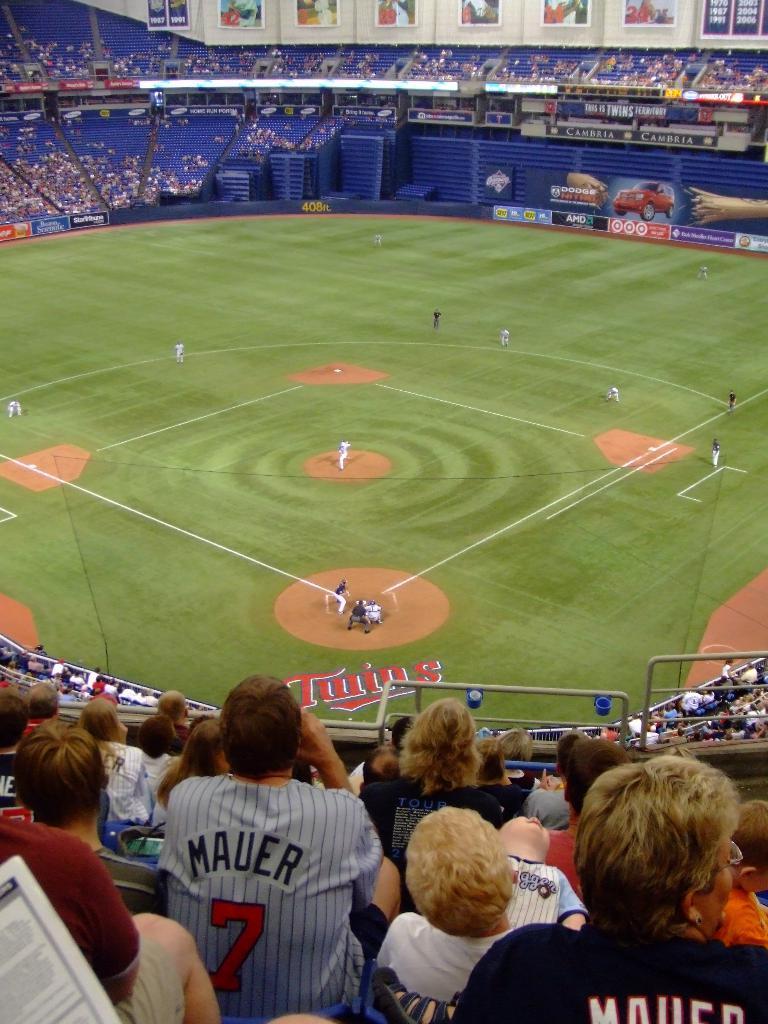In one or two sentences, can you explain what this image depicts? This image consists of a stadium. In which few persons are playing cricket. And we can see a huge crowd in the stadium. In the front, we can see the frames hanged on the wall. At the bottom, there is green grass on the ground. 